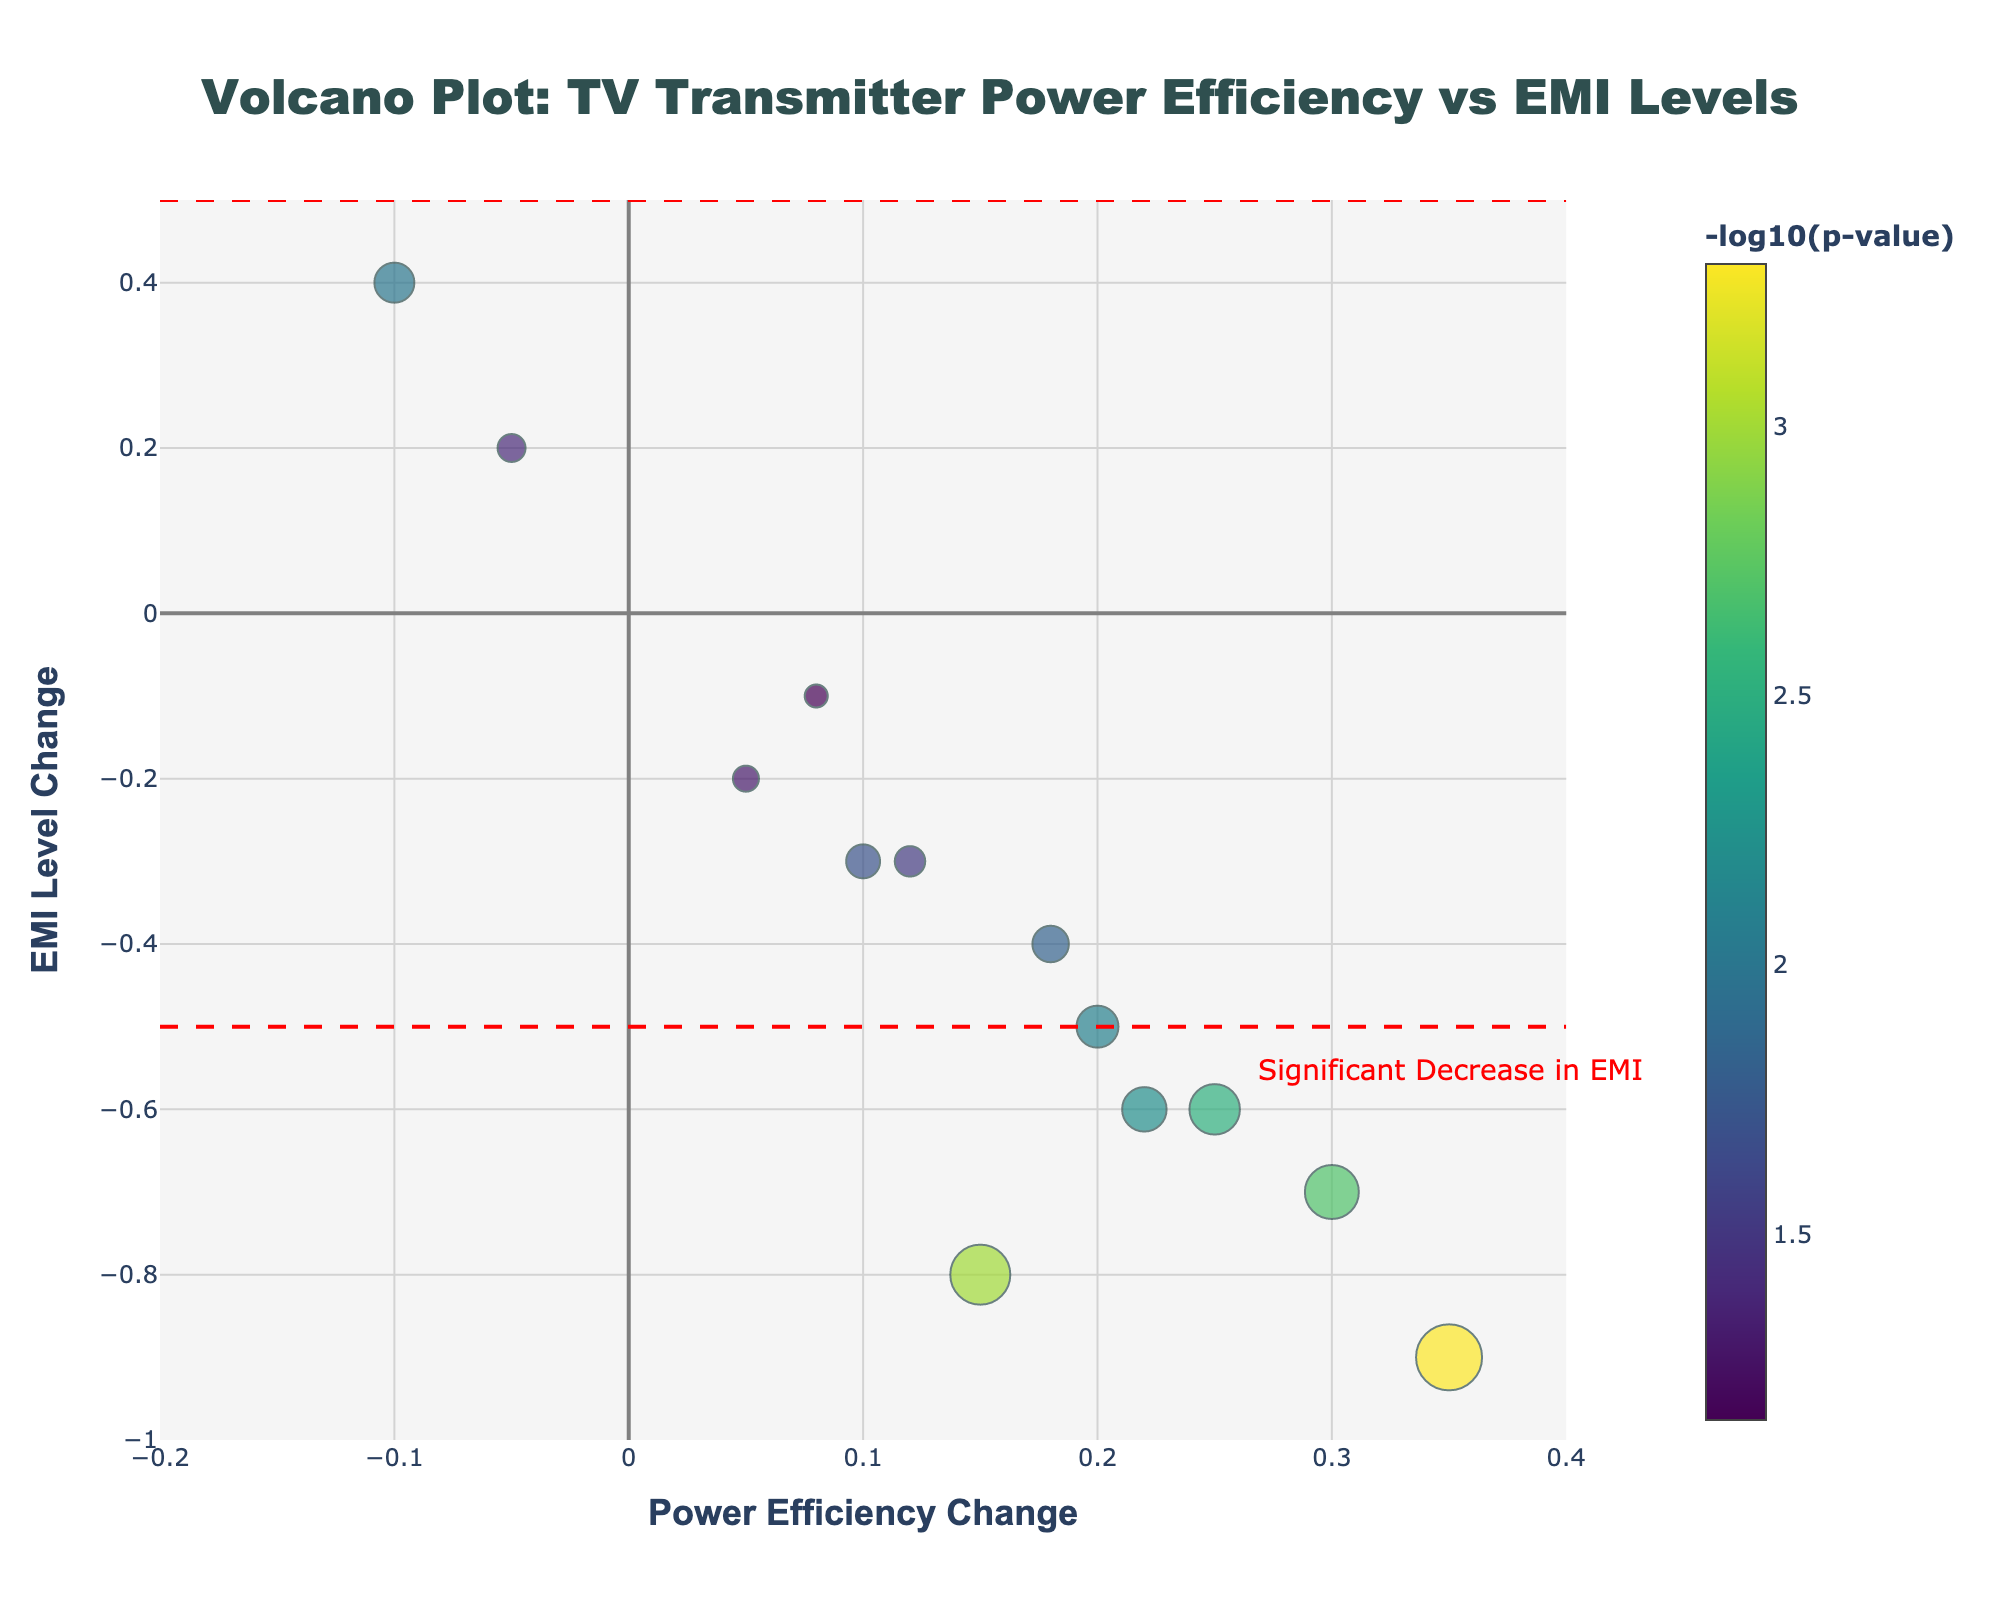How many data points are in the plot? Count the number of data points in the scatter plot. Each data point corresponds to a transmitter listed in the dataset.
Answer: 13 What does the x-axis represent in the figure? The x-axis label "<b>Power Efficiency Change</b>" indicates that it represents the change in power efficiency for different TV transmitters.
Answer: Power Efficiency Change What color scale is used for the markers in the scatter plot? The markers are colored using the "Viridis" color scale, which varies from purple to yellow as the value increases. This is indicated by the marker properties.
Answer: Viridis Which transmitter has the highest power efficiency change? To find the transmitter with the highest power efficiency change, look at the data point farthest to the right on the x-axis.
Answer: GaN_HEMT_Amplifier What is the range of EMI Level Change values in the plot? The y-axis is labeled "<b>EMI Level Change</b>", and the range is given from the grid and axis setup. The range is from -1 to 0.5.
Answer: -1 to 0.5 Which transmitter has the smallest p-value? The smallest p-value will correspond to the highest negative log10(p-value) among the markers. The size and color shade of the marker can guide us. GaN_HEMT_Amplifier has the highest negative log10(p-value).
Answer: GaN_HEMT_Amplifier Which area of the plot indicates a significant decrease in EMI levels? The shaded areas and annotations in the plot indicate significant changes. The "Significant Decrease in EMI" annotation is near the bottom part of the plot, showing EMI Level Change < -0.5.
Answer: EMI Level Change < -0.5 Compare the power efficiency change of ATSC_3.0_Exciter and DVB-T2_Amplifier. Which one is higher? Look at the x-coordinates of the points for ATSC_3.0_Exciter (x=0.15) and DVB-T2_Amplifier (x=0.25) on the scatter plot.
Answer: DVB-T2_Amplifier Which transmitter shows an increase in EMI levels and a decrease in power efficiency? The transmitter with an increase in EMI levels will be in the y > 0 area, and decrease in power efficiency will be x < 0 area. OFDM_Booster is located in this region.
Answer: OFDM_Booster 